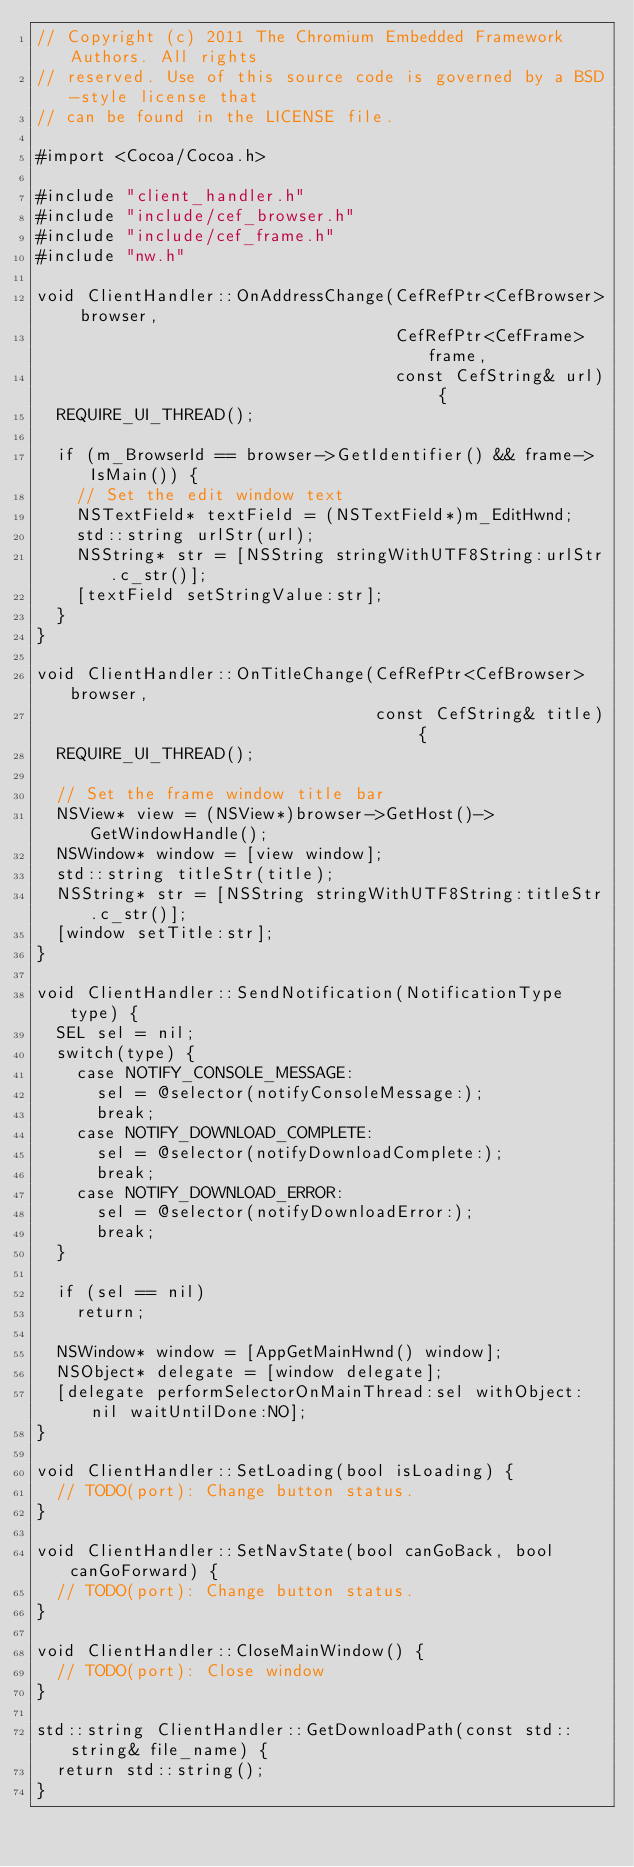<code> <loc_0><loc_0><loc_500><loc_500><_ObjectiveC_>// Copyright (c) 2011 The Chromium Embedded Framework Authors. All rights
// reserved. Use of this source code is governed by a BSD-style license that
// can be found in the LICENSE file.

#import <Cocoa/Cocoa.h>

#include "client_handler.h"
#include "include/cef_browser.h"
#include "include/cef_frame.h"
#include "nw.h"

void ClientHandler::OnAddressChange(CefRefPtr<CefBrowser> browser,
                                    CefRefPtr<CefFrame> frame,
                                    const CefString& url) {
  REQUIRE_UI_THREAD();

  if (m_BrowserId == browser->GetIdentifier() && frame->IsMain()) {
    // Set the edit window text
    NSTextField* textField = (NSTextField*)m_EditHwnd;
    std::string urlStr(url);
    NSString* str = [NSString stringWithUTF8String:urlStr.c_str()];
    [textField setStringValue:str];
  }
}

void ClientHandler::OnTitleChange(CefRefPtr<CefBrowser> browser,
                                  const CefString& title) {
  REQUIRE_UI_THREAD();

  // Set the frame window title bar
  NSView* view = (NSView*)browser->GetHost()->GetWindowHandle();
  NSWindow* window = [view window];
  std::string titleStr(title);
  NSString* str = [NSString stringWithUTF8String:titleStr.c_str()];
  [window setTitle:str];
}

void ClientHandler::SendNotification(NotificationType type) {
  SEL sel = nil;
  switch(type) {
    case NOTIFY_CONSOLE_MESSAGE:
      sel = @selector(notifyConsoleMessage:);
      break;
    case NOTIFY_DOWNLOAD_COMPLETE:
      sel = @selector(notifyDownloadComplete:);
      break;
    case NOTIFY_DOWNLOAD_ERROR:
      sel = @selector(notifyDownloadError:);
      break;
  }

  if (sel == nil)
    return;

  NSWindow* window = [AppGetMainHwnd() window];
  NSObject* delegate = [window delegate];
  [delegate performSelectorOnMainThread:sel withObject:nil waitUntilDone:NO];
}

void ClientHandler::SetLoading(bool isLoading) {
  // TODO(port): Change button status.
}

void ClientHandler::SetNavState(bool canGoBack, bool canGoForward) {
  // TODO(port): Change button status.
}

void ClientHandler::CloseMainWindow() {
  // TODO(port): Close window
}

std::string ClientHandler::GetDownloadPath(const std::string& file_name) {
  return std::string();
}
</code> 